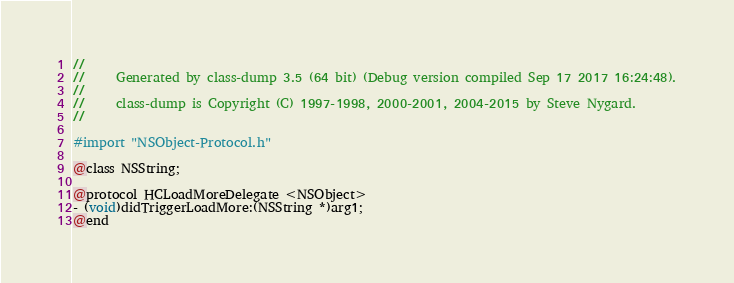Convert code to text. <code><loc_0><loc_0><loc_500><loc_500><_C_>//
//     Generated by class-dump 3.5 (64 bit) (Debug version compiled Sep 17 2017 16:24:48).
//
//     class-dump is Copyright (C) 1997-1998, 2000-2001, 2004-2015 by Steve Nygard.
//

#import "NSObject-Protocol.h"

@class NSString;

@protocol HCLoadMoreDelegate <NSObject>
- (void)didTriggerLoadMore:(NSString *)arg1;
@end

</code> 